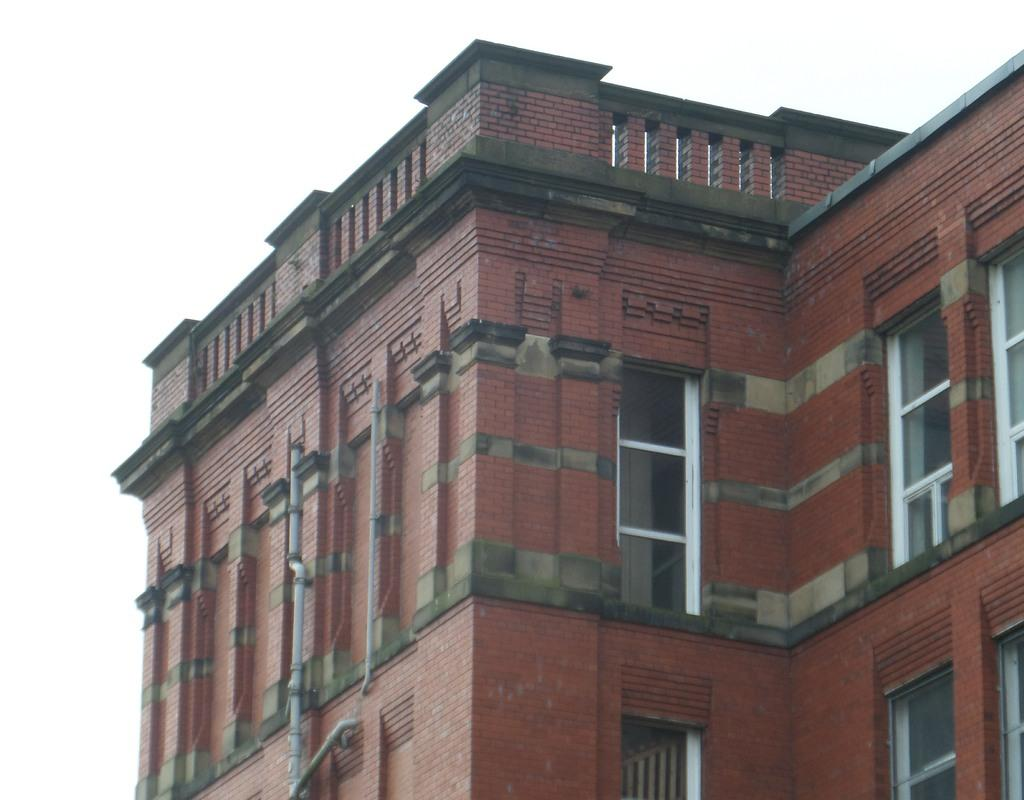What is the main structure in the image? There is a building in the image. What feature can be seen on the building? The building has windows. What color is the background of the image? The background of the image is white. What type of equipment is attached to the building? There are pipes attached to the building. What type of zinc is present in the image? There is no zinc present in the image. How many sacks can be seen in the image? There are no sacks visible in the image. 